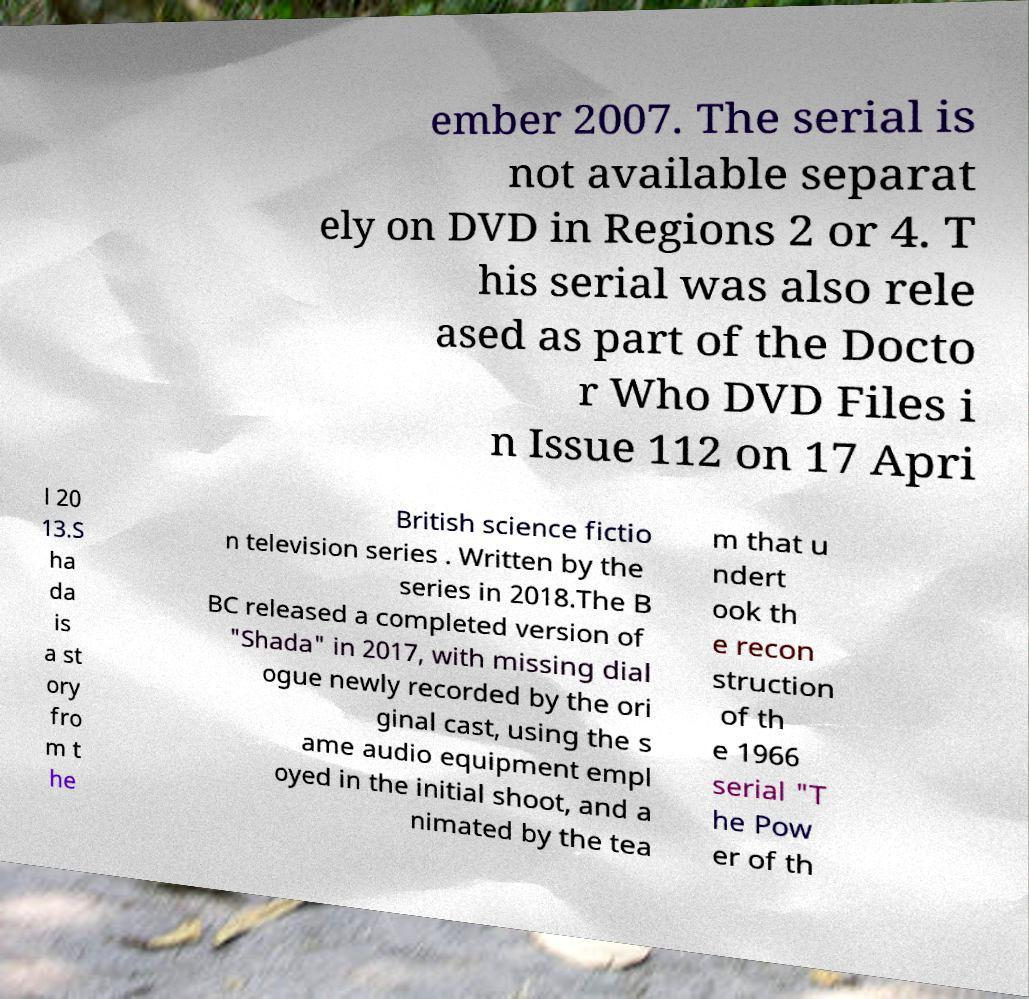Can you accurately transcribe the text from the provided image for me? ember 2007. The serial is not available separat ely on DVD in Regions 2 or 4. T his serial was also rele ased as part of the Docto r Who DVD Files i n Issue 112 on 17 Apri l 20 13.S ha da is a st ory fro m t he British science fictio n television series . Written by the series in 2018.The B BC released a completed version of "Shada" in 2017, with missing dial ogue newly recorded by the ori ginal cast, using the s ame audio equipment empl oyed in the initial shoot, and a nimated by the tea m that u ndert ook th e recon struction of th e 1966 serial "T he Pow er of th 